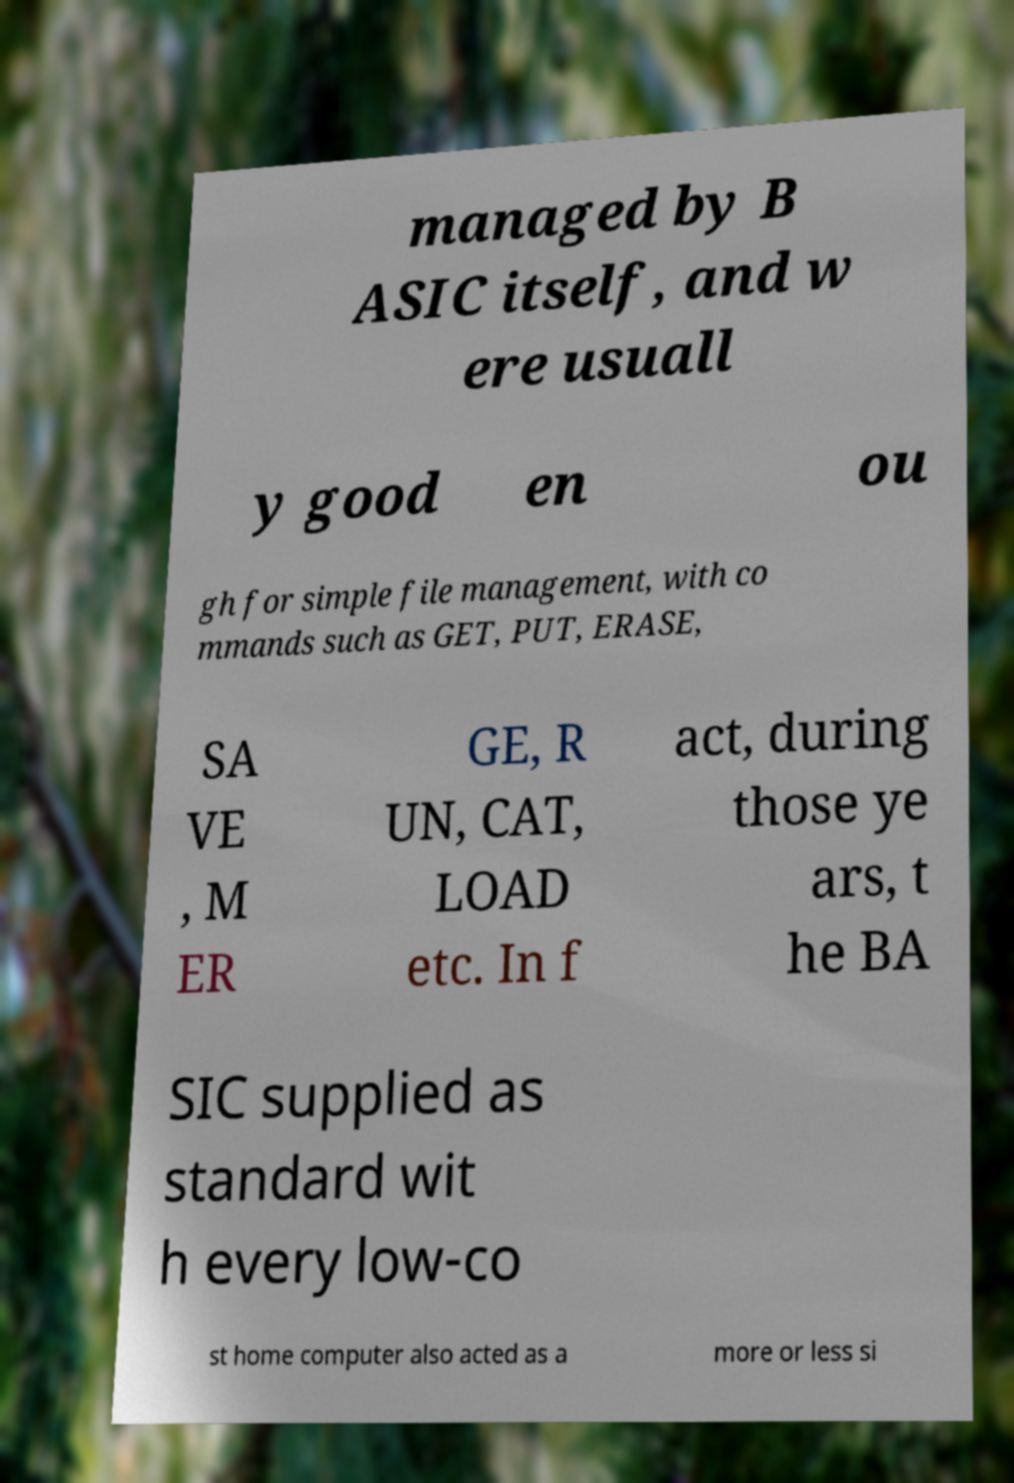Could you assist in decoding the text presented in this image and type it out clearly? managed by B ASIC itself, and w ere usuall y good en ou gh for simple file management, with co mmands such as GET, PUT, ERASE, SA VE , M ER GE, R UN, CAT, LOAD etc. In f act, during those ye ars, t he BA SIC supplied as standard wit h every low-co st home computer also acted as a more or less si 